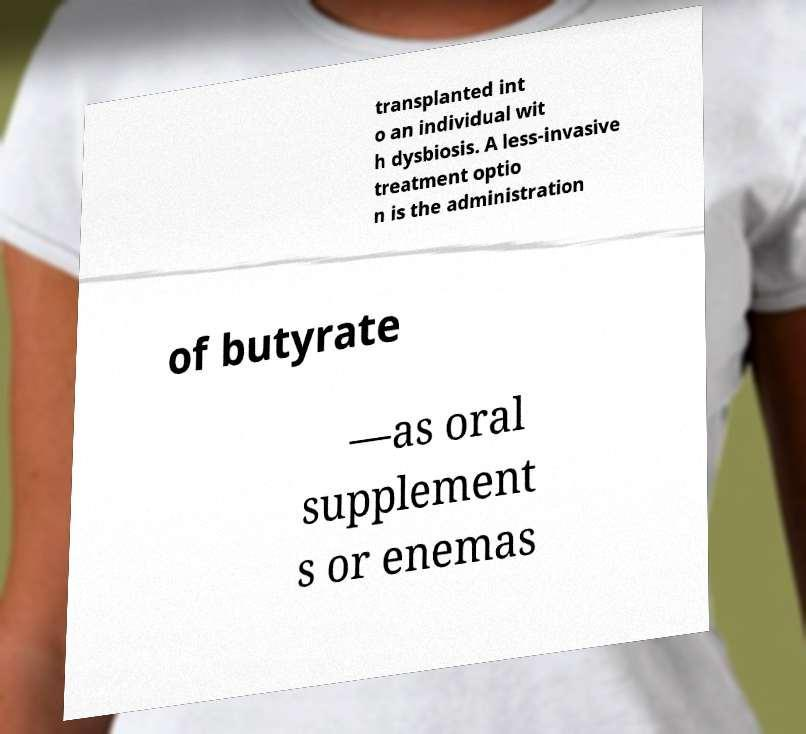Please identify and transcribe the text found in this image. transplanted int o an individual wit h dysbiosis. A less-invasive treatment optio n is the administration of butyrate —as oral supplement s or enemas 